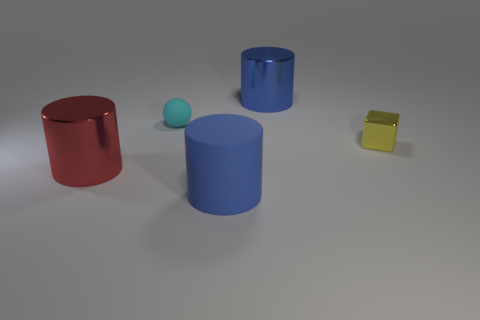Is the number of blue shiny objects behind the tiny cyan sphere greater than the number of big rubber things that are on the left side of the blue rubber thing? yes 